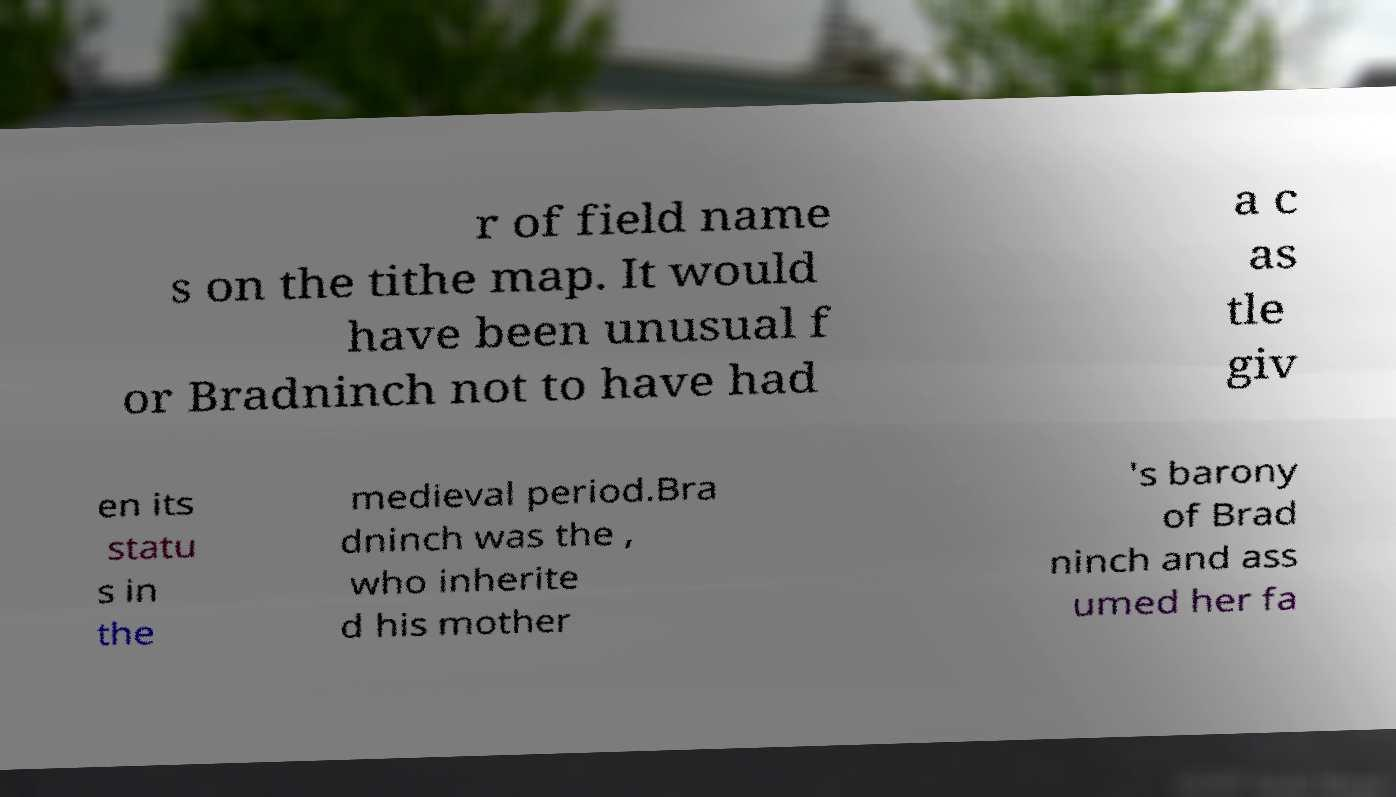Can you accurately transcribe the text from the provided image for me? r of field name s on the tithe map. It would have been unusual f or Bradninch not to have had a c as tle giv en its statu s in the medieval period.Bra dninch was the , who inherite d his mother 's barony of Brad ninch and ass umed her fa 